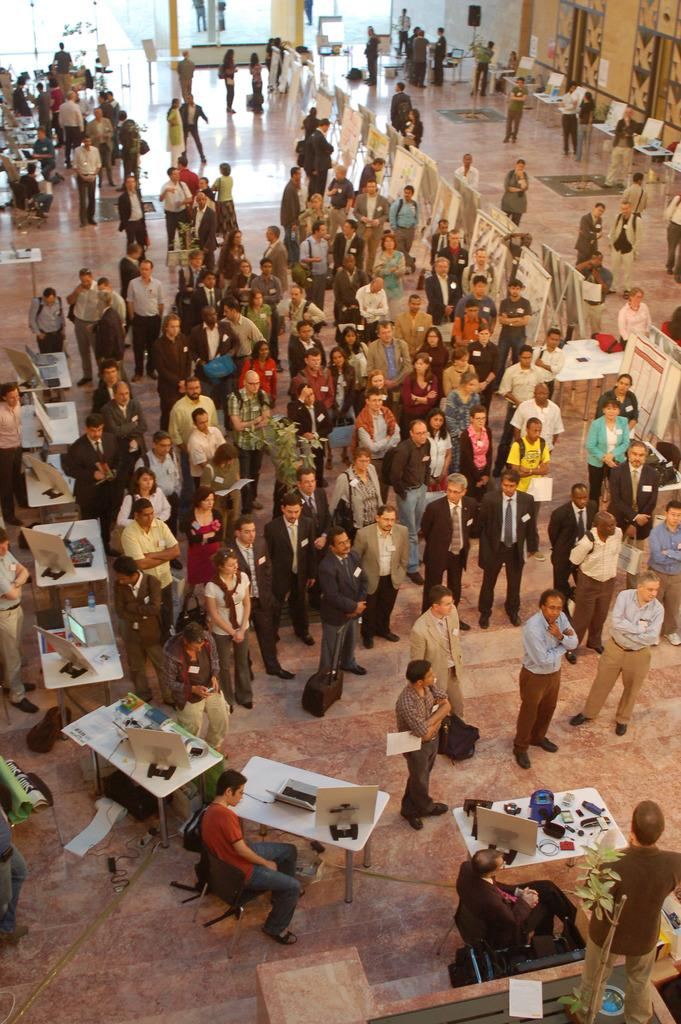Who is present in the image? There are people in the image. Where are the people gathered? The people are gathered at a fair. What is the location of the fair? The fair is taking place in a hall. What type of shelf can be seen in the image? There is no shelf present in the image; it features people at a fair in a hall. 